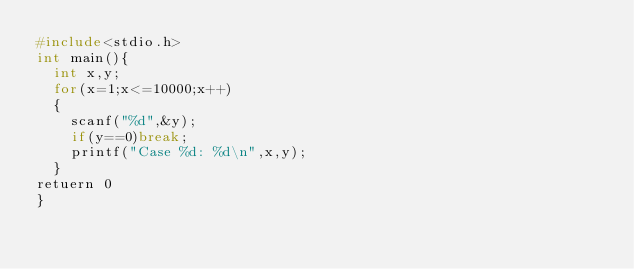<code> <loc_0><loc_0><loc_500><loc_500><_C_>#include<stdio.h>
int main(){
	int x,y;
	for(x=1;x<=10000;x++)
	{
		scanf("%d",&y);
		if(y==0)break;
		printf("Case %d: %d\n",x,y);
	}
retuern 0
}</code> 